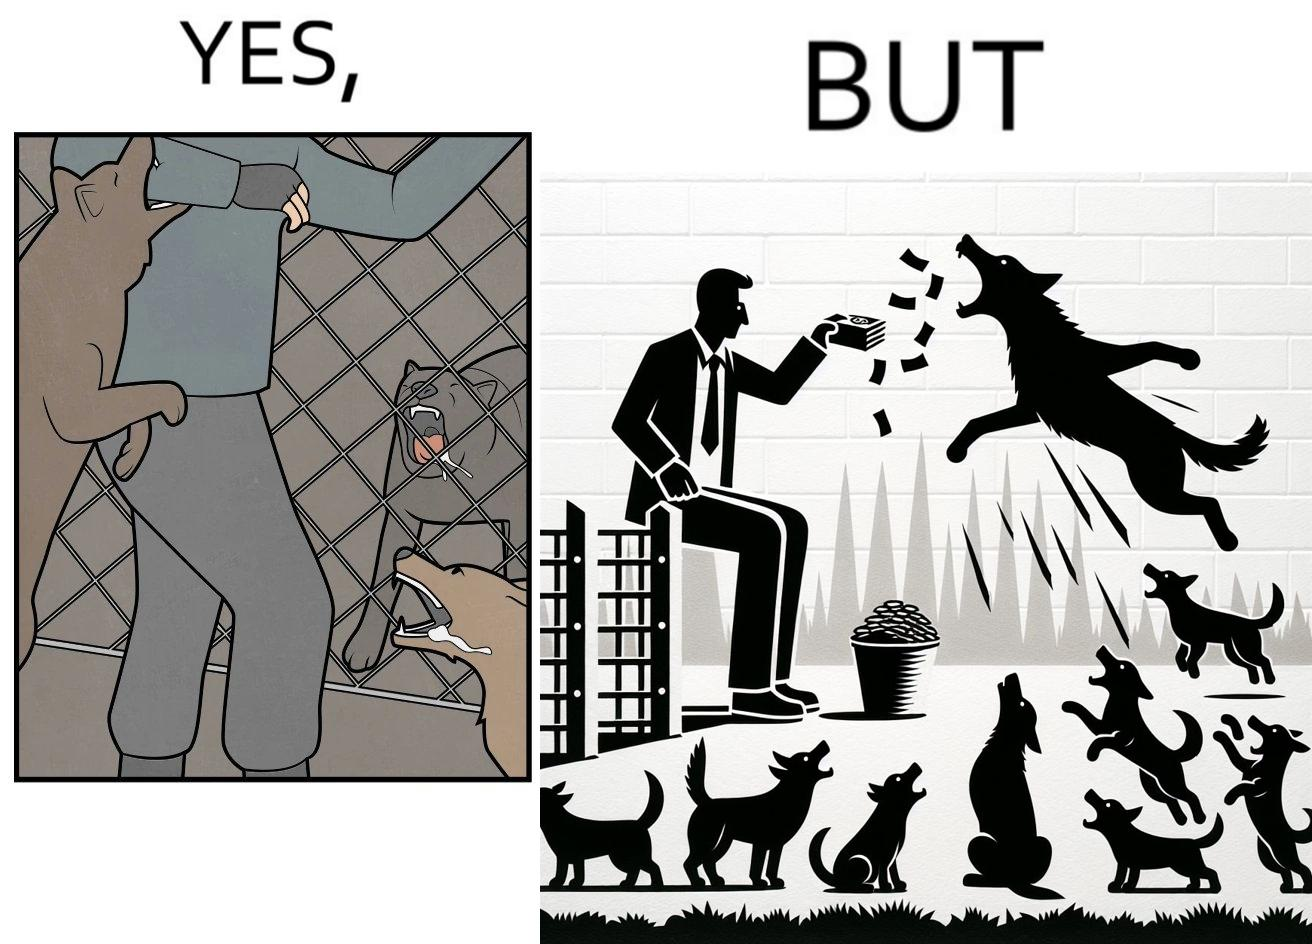Describe what you see in the left and right parts of this image. In the left part of the image: It is a man donating money to a dog shelter while dogs are barking at him In the right part of the image: It is a man donating money to a dog shelter while dogs are barking at him and one of the dogs is attacking him 